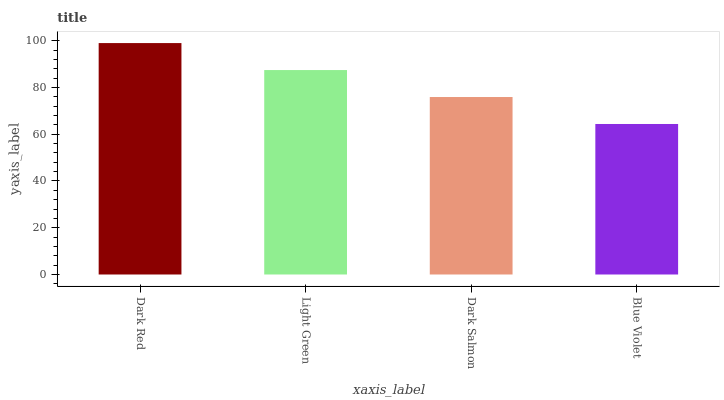Is Blue Violet the minimum?
Answer yes or no. Yes. Is Dark Red the maximum?
Answer yes or no. Yes. Is Light Green the minimum?
Answer yes or no. No. Is Light Green the maximum?
Answer yes or no. No. Is Dark Red greater than Light Green?
Answer yes or no. Yes. Is Light Green less than Dark Red?
Answer yes or no. Yes. Is Light Green greater than Dark Red?
Answer yes or no. No. Is Dark Red less than Light Green?
Answer yes or no. No. Is Light Green the high median?
Answer yes or no. Yes. Is Dark Salmon the low median?
Answer yes or no. Yes. Is Blue Violet the high median?
Answer yes or no. No. Is Blue Violet the low median?
Answer yes or no. No. 